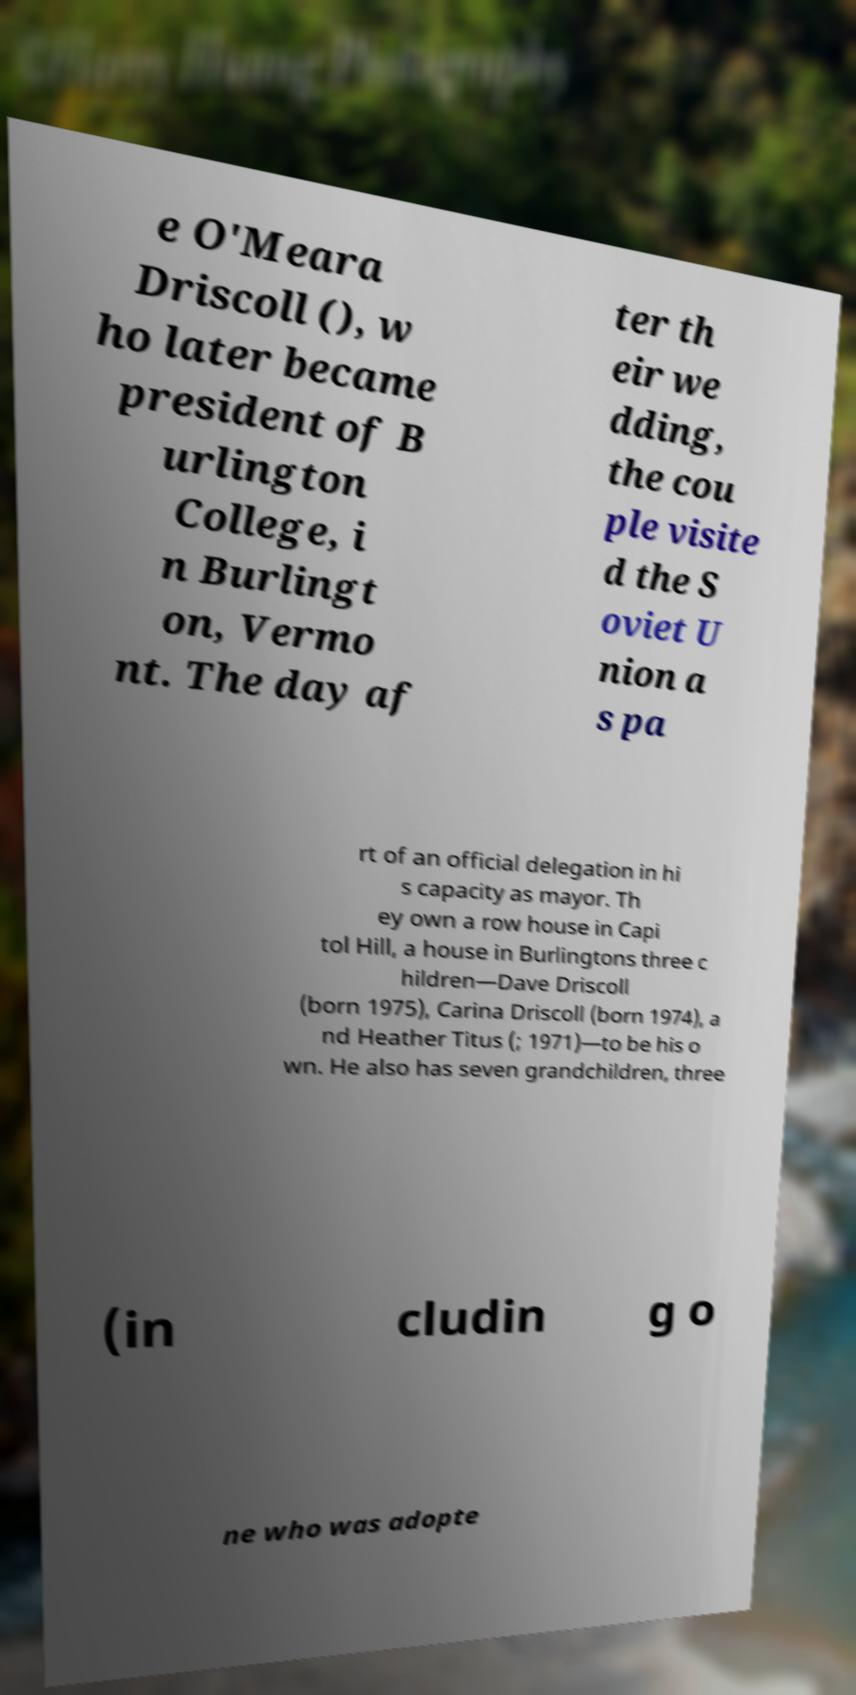Could you assist in decoding the text presented in this image and type it out clearly? e O'Meara Driscoll (), w ho later became president of B urlington College, i n Burlingt on, Vermo nt. The day af ter th eir we dding, the cou ple visite d the S oviet U nion a s pa rt of an official delegation in hi s capacity as mayor. Th ey own a row house in Capi tol Hill, a house in Burlingtons three c hildren—Dave Driscoll (born 1975), Carina Driscoll (born 1974), a nd Heather Titus (; 1971)—to be his o wn. He also has seven grandchildren, three (in cludin g o ne who was adopte 